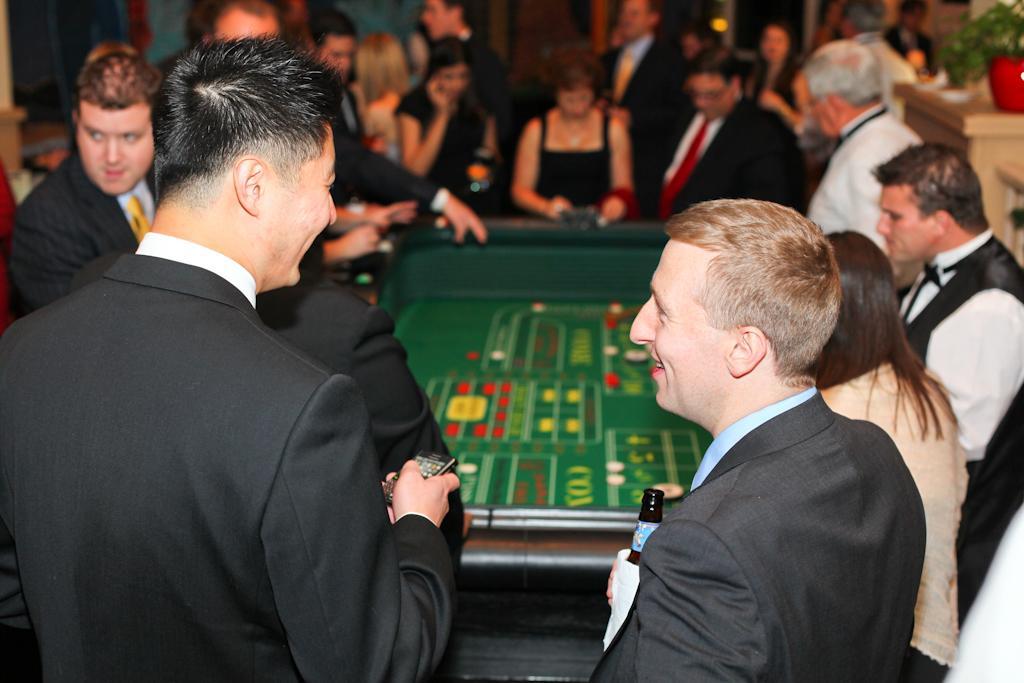Can you describe this image briefly? In this image I see number of people in which few of them are suits and I see that this man is holding a mobile phone in his hand and this man is holding a bottle in his hand and I see the table over here and I see that it is blurred in the background and I see a plant in this pot. 